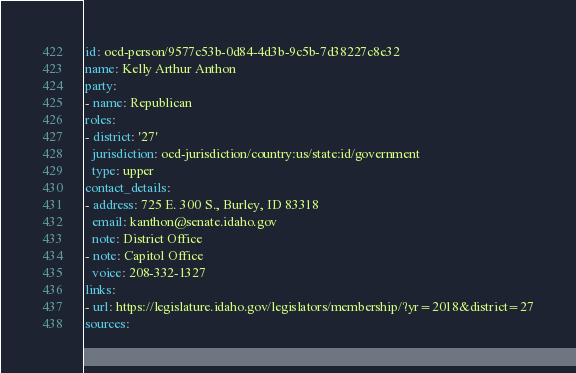<code> <loc_0><loc_0><loc_500><loc_500><_YAML_>id: ocd-person/9577c53b-0d84-4d3b-9c5b-7d38227c8e32
name: Kelly Arthur Anthon
party:
- name: Republican
roles:
- district: '27'
  jurisdiction: ocd-jurisdiction/country:us/state:id/government
  type: upper
contact_details:
- address: 725 E. 300 S., Burley, ID 83318
  email: kanthon@senate.idaho.gov
  note: District Office
- note: Capitol Office
  voice: 208-332-1327
links:
- url: https://legislature.idaho.gov/legislators/membership/?yr=2018&district=27
sources:</code> 